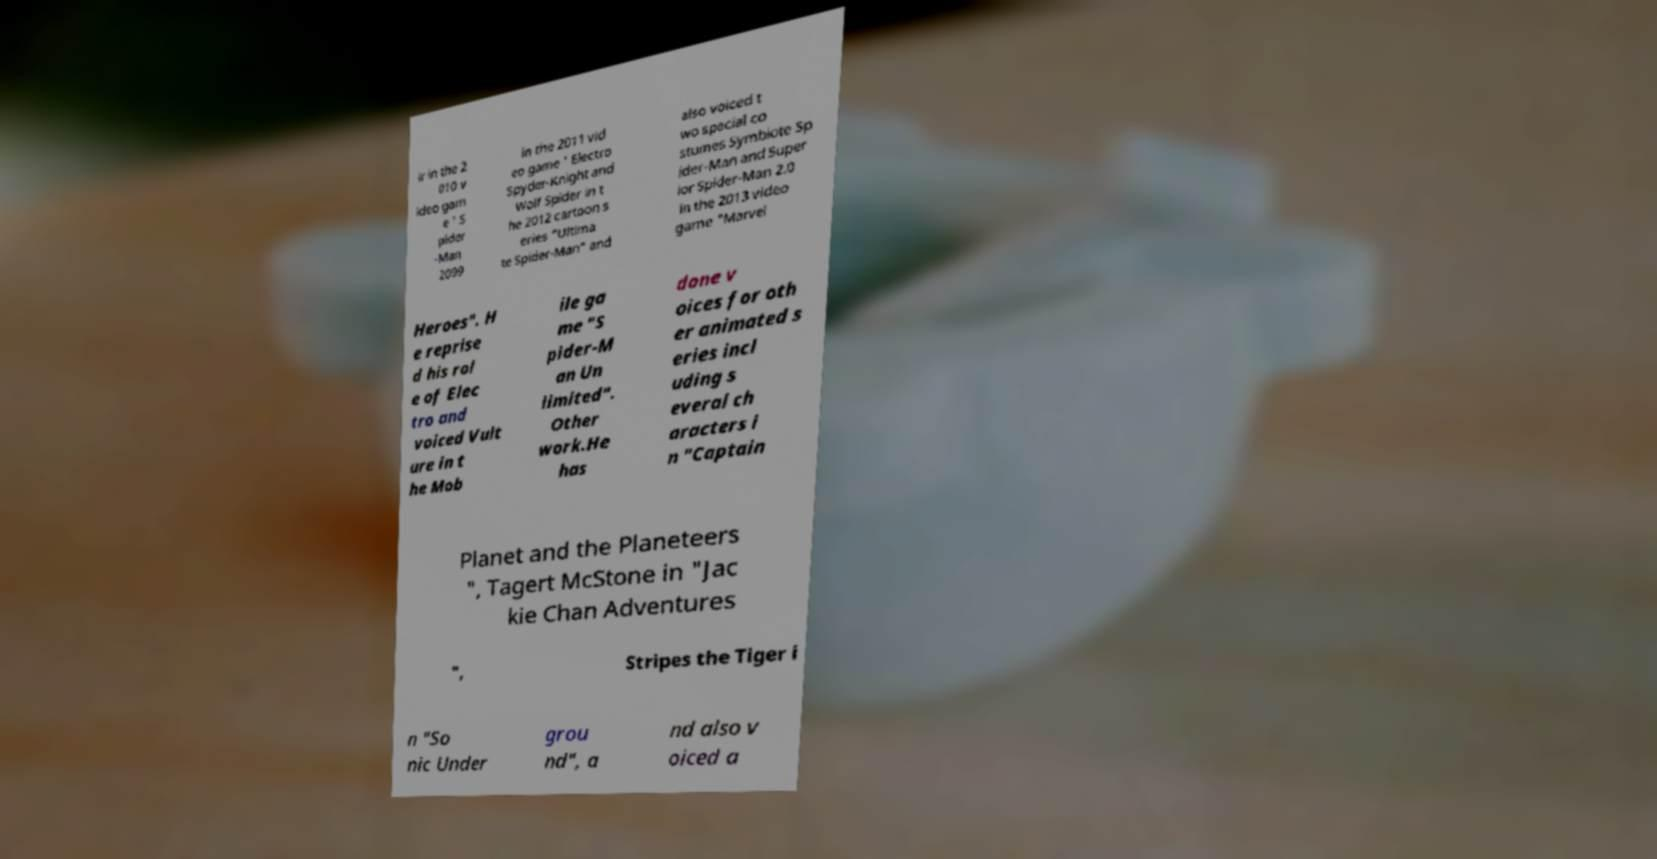Please read and relay the text visible in this image. What does it say? ir in the 2 010 v ideo gam e ' S pider -Man 2099 in the 2011 vid eo game ' Electro Spyder-Knight and Wolf Spider in t he 2012 cartoon s eries "Ultima te Spider-Man" and also voiced t wo special co stumes Symbiote Sp ider-Man and Super ior Spider-Man 2.0 in the 2013 video game "Marvel Heroes". H e reprise d his rol e of Elec tro and voiced Vult ure in t he Mob ile ga me "S pider-M an Un limited". Other work.He has done v oices for oth er animated s eries incl uding s everal ch aracters i n "Captain Planet and the Planeteers ", Tagert McStone in "Jac kie Chan Adventures ", Stripes the Tiger i n "So nic Under grou nd", a nd also v oiced a 